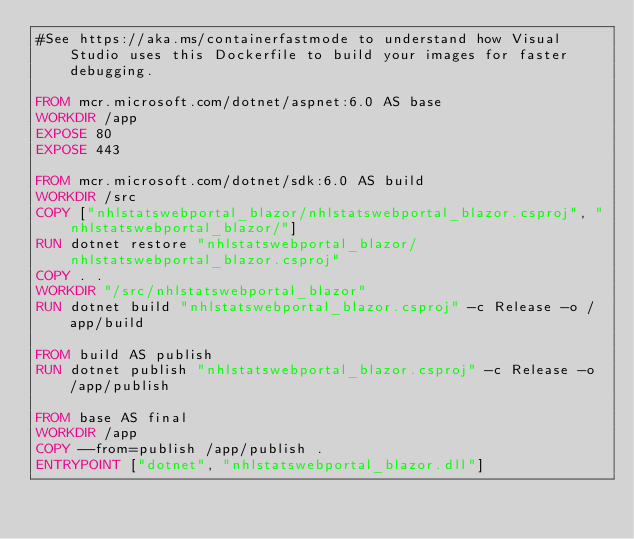<code> <loc_0><loc_0><loc_500><loc_500><_Dockerfile_>#See https://aka.ms/containerfastmode to understand how Visual Studio uses this Dockerfile to build your images for faster debugging.

FROM mcr.microsoft.com/dotnet/aspnet:6.0 AS base
WORKDIR /app
EXPOSE 80
EXPOSE 443

FROM mcr.microsoft.com/dotnet/sdk:6.0 AS build
WORKDIR /src
COPY ["nhlstatswebportal_blazor/nhlstatswebportal_blazor.csproj", "nhlstatswebportal_blazor/"]
RUN dotnet restore "nhlstatswebportal_blazor/nhlstatswebportal_blazor.csproj"
COPY . .
WORKDIR "/src/nhlstatswebportal_blazor"
RUN dotnet build "nhlstatswebportal_blazor.csproj" -c Release -o /app/build

FROM build AS publish
RUN dotnet publish "nhlstatswebportal_blazor.csproj" -c Release -o /app/publish

FROM base AS final
WORKDIR /app
COPY --from=publish /app/publish .
ENTRYPOINT ["dotnet", "nhlstatswebportal_blazor.dll"]</code> 